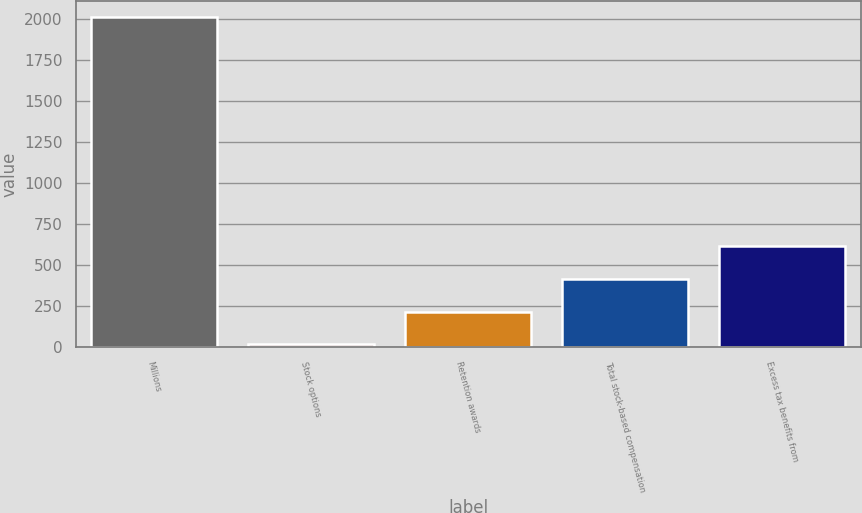<chart> <loc_0><loc_0><loc_500><loc_500><bar_chart><fcel>Millions<fcel>Stock options<fcel>Retention awards<fcel>Total stock-based compensation<fcel>Excess tax benefits from<nl><fcel>2012<fcel>18<fcel>217.4<fcel>416.8<fcel>616.2<nl></chart> 